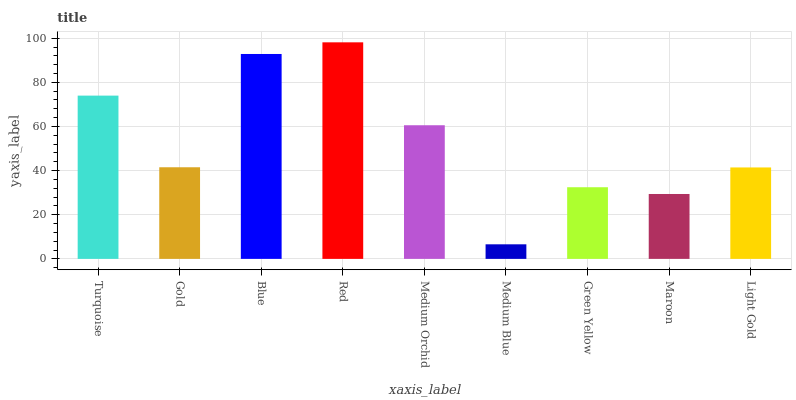Is Medium Blue the minimum?
Answer yes or no. Yes. Is Red the maximum?
Answer yes or no. Yes. Is Gold the minimum?
Answer yes or no. No. Is Gold the maximum?
Answer yes or no. No. Is Turquoise greater than Gold?
Answer yes or no. Yes. Is Gold less than Turquoise?
Answer yes or no. Yes. Is Gold greater than Turquoise?
Answer yes or no. No. Is Turquoise less than Gold?
Answer yes or no. No. Is Gold the high median?
Answer yes or no. Yes. Is Gold the low median?
Answer yes or no. Yes. Is Red the high median?
Answer yes or no. No. Is Red the low median?
Answer yes or no. No. 